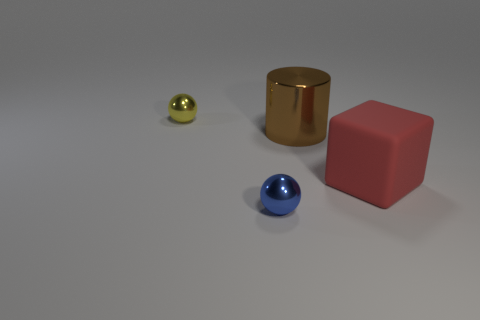How many big things are to the right of the brown cylinder and behind the large red object?
Offer a very short reply. 0. How many cubes are either blue matte things or blue metallic objects?
Your answer should be compact. 0. Are there any big yellow things?
Keep it short and to the point. No. How many other objects are there of the same material as the brown thing?
Your response must be concise. 2. What is the material of the object that is the same size as the yellow sphere?
Ensure brevity in your answer.  Metal. Does the small metal object that is in front of the tiny yellow metal thing have the same shape as the yellow object?
Offer a terse response. Yes. How many objects are tiny balls right of the small yellow ball or large red things?
Make the answer very short. 2. There is a brown shiny thing that is the same size as the red block; what is its shape?
Your response must be concise. Cylinder. There is a thing that is to the right of the cylinder; is it the same size as the brown metallic object that is behind the cube?
Provide a short and direct response. Yes. There is another small ball that is made of the same material as the small blue sphere; what color is it?
Ensure brevity in your answer.  Yellow. 